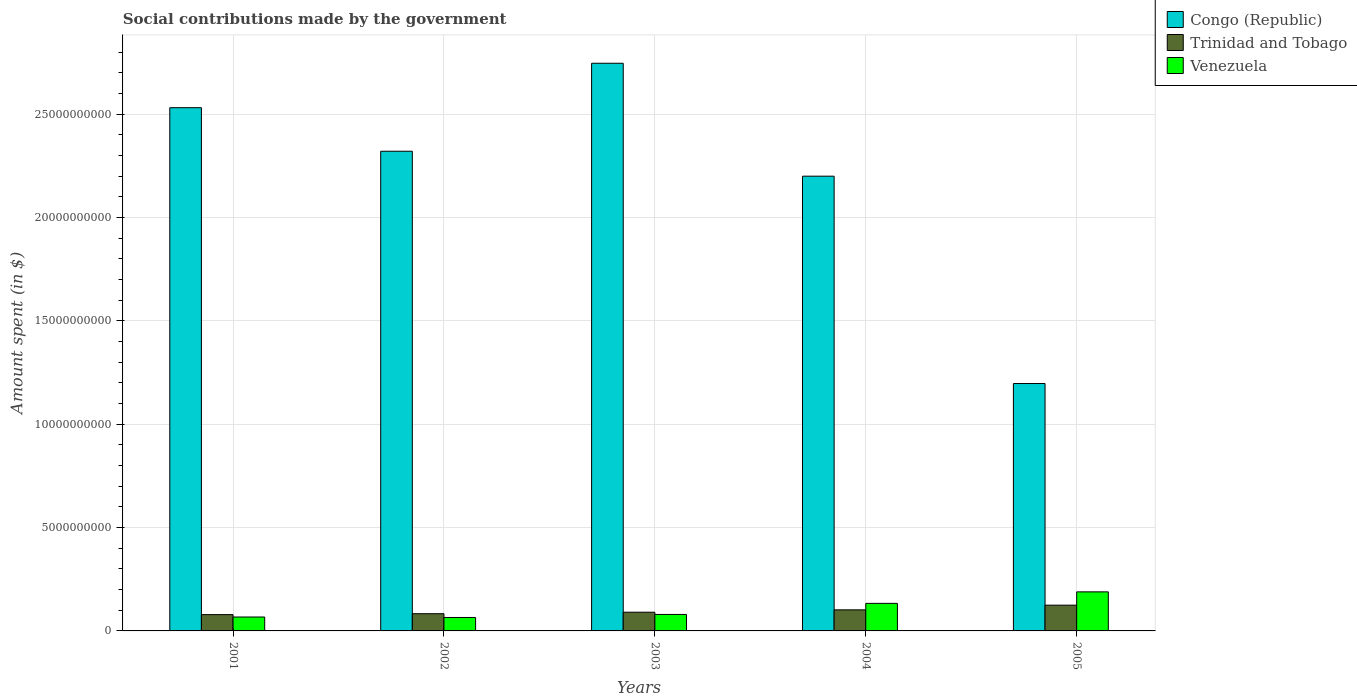How many groups of bars are there?
Make the answer very short. 5. Are the number of bars per tick equal to the number of legend labels?
Give a very brief answer. Yes. How many bars are there on the 5th tick from the right?
Your answer should be very brief. 3. What is the label of the 5th group of bars from the left?
Provide a short and direct response. 2005. In how many cases, is the number of bars for a given year not equal to the number of legend labels?
Offer a very short reply. 0. What is the amount spent on social contributions in Congo (Republic) in 2005?
Your response must be concise. 1.20e+1. Across all years, what is the maximum amount spent on social contributions in Trinidad and Tobago?
Your answer should be very brief. 1.25e+09. Across all years, what is the minimum amount spent on social contributions in Venezuela?
Your answer should be compact. 6.50e+08. In which year was the amount spent on social contributions in Congo (Republic) minimum?
Provide a succinct answer. 2005. What is the total amount spent on social contributions in Congo (Republic) in the graph?
Your answer should be very brief. 1.10e+11. What is the difference between the amount spent on social contributions in Venezuela in 2002 and that in 2004?
Provide a succinct answer. -6.83e+08. What is the difference between the amount spent on social contributions in Congo (Republic) in 2003 and the amount spent on social contributions in Venezuela in 2002?
Give a very brief answer. 2.68e+1. What is the average amount spent on social contributions in Venezuela per year?
Provide a short and direct response. 1.07e+09. In the year 2002, what is the difference between the amount spent on social contributions in Trinidad and Tobago and amount spent on social contributions in Venezuela?
Provide a short and direct response. 1.83e+08. What is the ratio of the amount spent on social contributions in Venezuela in 2003 to that in 2005?
Your response must be concise. 0.42. What is the difference between the highest and the second highest amount spent on social contributions in Congo (Republic)?
Keep it short and to the point. 2.15e+09. What is the difference between the highest and the lowest amount spent on social contributions in Congo (Republic)?
Your answer should be very brief. 1.55e+1. What does the 3rd bar from the left in 2004 represents?
Ensure brevity in your answer.  Venezuela. What does the 2nd bar from the right in 2002 represents?
Provide a succinct answer. Trinidad and Tobago. Is it the case that in every year, the sum of the amount spent on social contributions in Congo (Republic) and amount spent on social contributions in Trinidad and Tobago is greater than the amount spent on social contributions in Venezuela?
Your answer should be compact. Yes. Are all the bars in the graph horizontal?
Give a very brief answer. No. Are the values on the major ticks of Y-axis written in scientific E-notation?
Provide a succinct answer. No. Does the graph contain any zero values?
Ensure brevity in your answer.  No. Does the graph contain grids?
Your answer should be compact. Yes. What is the title of the graph?
Provide a succinct answer. Social contributions made by the government. Does "Angola" appear as one of the legend labels in the graph?
Provide a short and direct response. No. What is the label or title of the X-axis?
Provide a short and direct response. Years. What is the label or title of the Y-axis?
Offer a terse response. Amount spent (in $). What is the Amount spent (in $) in Congo (Republic) in 2001?
Your answer should be very brief. 2.53e+1. What is the Amount spent (in $) of Trinidad and Tobago in 2001?
Keep it short and to the point. 7.89e+08. What is the Amount spent (in $) in Venezuela in 2001?
Ensure brevity in your answer.  6.74e+08. What is the Amount spent (in $) of Congo (Republic) in 2002?
Provide a short and direct response. 2.32e+1. What is the Amount spent (in $) in Trinidad and Tobago in 2002?
Give a very brief answer. 8.33e+08. What is the Amount spent (in $) of Venezuela in 2002?
Provide a succinct answer. 6.50e+08. What is the Amount spent (in $) in Congo (Republic) in 2003?
Keep it short and to the point. 2.75e+1. What is the Amount spent (in $) of Trinidad and Tobago in 2003?
Provide a short and direct response. 9.06e+08. What is the Amount spent (in $) in Venezuela in 2003?
Provide a succinct answer. 7.97e+08. What is the Amount spent (in $) in Congo (Republic) in 2004?
Your response must be concise. 2.20e+1. What is the Amount spent (in $) of Trinidad and Tobago in 2004?
Make the answer very short. 1.02e+09. What is the Amount spent (in $) of Venezuela in 2004?
Ensure brevity in your answer.  1.33e+09. What is the Amount spent (in $) of Congo (Republic) in 2005?
Provide a succinct answer. 1.20e+1. What is the Amount spent (in $) of Trinidad and Tobago in 2005?
Give a very brief answer. 1.25e+09. What is the Amount spent (in $) in Venezuela in 2005?
Provide a succinct answer. 1.89e+09. Across all years, what is the maximum Amount spent (in $) of Congo (Republic)?
Your response must be concise. 2.75e+1. Across all years, what is the maximum Amount spent (in $) of Trinidad and Tobago?
Your answer should be compact. 1.25e+09. Across all years, what is the maximum Amount spent (in $) in Venezuela?
Keep it short and to the point. 1.89e+09. Across all years, what is the minimum Amount spent (in $) in Congo (Republic)?
Ensure brevity in your answer.  1.20e+1. Across all years, what is the minimum Amount spent (in $) of Trinidad and Tobago?
Provide a succinct answer. 7.89e+08. Across all years, what is the minimum Amount spent (in $) of Venezuela?
Your answer should be very brief. 6.50e+08. What is the total Amount spent (in $) in Congo (Republic) in the graph?
Make the answer very short. 1.10e+11. What is the total Amount spent (in $) in Trinidad and Tobago in the graph?
Ensure brevity in your answer.  4.79e+09. What is the total Amount spent (in $) of Venezuela in the graph?
Provide a short and direct response. 5.34e+09. What is the difference between the Amount spent (in $) of Congo (Republic) in 2001 and that in 2002?
Your response must be concise. 2.11e+09. What is the difference between the Amount spent (in $) of Trinidad and Tobago in 2001 and that in 2002?
Make the answer very short. -4.38e+07. What is the difference between the Amount spent (in $) of Venezuela in 2001 and that in 2002?
Offer a terse response. 2.32e+07. What is the difference between the Amount spent (in $) of Congo (Republic) in 2001 and that in 2003?
Provide a succinct answer. -2.15e+09. What is the difference between the Amount spent (in $) in Trinidad and Tobago in 2001 and that in 2003?
Your answer should be compact. -1.16e+08. What is the difference between the Amount spent (in $) of Venezuela in 2001 and that in 2003?
Offer a terse response. -1.23e+08. What is the difference between the Amount spent (in $) of Congo (Republic) in 2001 and that in 2004?
Provide a succinct answer. 3.31e+09. What is the difference between the Amount spent (in $) in Trinidad and Tobago in 2001 and that in 2004?
Make the answer very short. -2.30e+08. What is the difference between the Amount spent (in $) in Venezuela in 2001 and that in 2004?
Offer a very short reply. -6.60e+08. What is the difference between the Amount spent (in $) of Congo (Republic) in 2001 and that in 2005?
Provide a short and direct response. 1.33e+1. What is the difference between the Amount spent (in $) of Trinidad and Tobago in 2001 and that in 2005?
Offer a terse response. -4.57e+08. What is the difference between the Amount spent (in $) in Venezuela in 2001 and that in 2005?
Ensure brevity in your answer.  -1.22e+09. What is the difference between the Amount spent (in $) of Congo (Republic) in 2002 and that in 2003?
Provide a short and direct response. -4.26e+09. What is the difference between the Amount spent (in $) of Trinidad and Tobago in 2002 and that in 2003?
Provide a succinct answer. -7.26e+07. What is the difference between the Amount spent (in $) in Venezuela in 2002 and that in 2003?
Make the answer very short. -1.46e+08. What is the difference between the Amount spent (in $) of Congo (Republic) in 2002 and that in 2004?
Offer a very short reply. 1.21e+09. What is the difference between the Amount spent (in $) in Trinidad and Tobago in 2002 and that in 2004?
Your answer should be compact. -1.87e+08. What is the difference between the Amount spent (in $) in Venezuela in 2002 and that in 2004?
Your answer should be very brief. -6.83e+08. What is the difference between the Amount spent (in $) in Congo (Republic) in 2002 and that in 2005?
Provide a short and direct response. 1.12e+1. What is the difference between the Amount spent (in $) in Trinidad and Tobago in 2002 and that in 2005?
Keep it short and to the point. -4.13e+08. What is the difference between the Amount spent (in $) in Venezuela in 2002 and that in 2005?
Keep it short and to the point. -1.24e+09. What is the difference between the Amount spent (in $) in Congo (Republic) in 2003 and that in 2004?
Your answer should be very brief. 5.46e+09. What is the difference between the Amount spent (in $) in Trinidad and Tobago in 2003 and that in 2004?
Offer a terse response. -1.14e+08. What is the difference between the Amount spent (in $) of Venezuela in 2003 and that in 2004?
Your answer should be compact. -5.37e+08. What is the difference between the Amount spent (in $) in Congo (Republic) in 2003 and that in 2005?
Make the answer very short. 1.55e+1. What is the difference between the Amount spent (in $) in Trinidad and Tobago in 2003 and that in 2005?
Keep it short and to the point. -3.40e+08. What is the difference between the Amount spent (in $) in Venezuela in 2003 and that in 2005?
Offer a terse response. -1.09e+09. What is the difference between the Amount spent (in $) in Congo (Republic) in 2004 and that in 2005?
Give a very brief answer. 1.00e+1. What is the difference between the Amount spent (in $) in Trinidad and Tobago in 2004 and that in 2005?
Keep it short and to the point. -2.26e+08. What is the difference between the Amount spent (in $) in Venezuela in 2004 and that in 2005?
Offer a very short reply. -5.56e+08. What is the difference between the Amount spent (in $) in Congo (Republic) in 2001 and the Amount spent (in $) in Trinidad and Tobago in 2002?
Your response must be concise. 2.45e+1. What is the difference between the Amount spent (in $) of Congo (Republic) in 2001 and the Amount spent (in $) of Venezuela in 2002?
Provide a succinct answer. 2.47e+1. What is the difference between the Amount spent (in $) in Trinidad and Tobago in 2001 and the Amount spent (in $) in Venezuela in 2002?
Ensure brevity in your answer.  1.39e+08. What is the difference between the Amount spent (in $) of Congo (Republic) in 2001 and the Amount spent (in $) of Trinidad and Tobago in 2003?
Your answer should be very brief. 2.44e+1. What is the difference between the Amount spent (in $) of Congo (Republic) in 2001 and the Amount spent (in $) of Venezuela in 2003?
Ensure brevity in your answer.  2.45e+1. What is the difference between the Amount spent (in $) in Trinidad and Tobago in 2001 and the Amount spent (in $) in Venezuela in 2003?
Give a very brief answer. -7.62e+06. What is the difference between the Amount spent (in $) of Congo (Republic) in 2001 and the Amount spent (in $) of Trinidad and Tobago in 2004?
Your answer should be compact. 2.43e+1. What is the difference between the Amount spent (in $) in Congo (Republic) in 2001 and the Amount spent (in $) in Venezuela in 2004?
Make the answer very short. 2.40e+1. What is the difference between the Amount spent (in $) of Trinidad and Tobago in 2001 and the Amount spent (in $) of Venezuela in 2004?
Your response must be concise. -5.44e+08. What is the difference between the Amount spent (in $) of Congo (Republic) in 2001 and the Amount spent (in $) of Trinidad and Tobago in 2005?
Your answer should be very brief. 2.41e+1. What is the difference between the Amount spent (in $) in Congo (Republic) in 2001 and the Amount spent (in $) in Venezuela in 2005?
Make the answer very short. 2.34e+1. What is the difference between the Amount spent (in $) of Trinidad and Tobago in 2001 and the Amount spent (in $) of Venezuela in 2005?
Offer a very short reply. -1.10e+09. What is the difference between the Amount spent (in $) of Congo (Republic) in 2002 and the Amount spent (in $) of Trinidad and Tobago in 2003?
Make the answer very short. 2.23e+1. What is the difference between the Amount spent (in $) of Congo (Republic) in 2002 and the Amount spent (in $) of Venezuela in 2003?
Your response must be concise. 2.24e+1. What is the difference between the Amount spent (in $) of Trinidad and Tobago in 2002 and the Amount spent (in $) of Venezuela in 2003?
Make the answer very short. 3.62e+07. What is the difference between the Amount spent (in $) in Congo (Republic) in 2002 and the Amount spent (in $) in Trinidad and Tobago in 2004?
Provide a short and direct response. 2.22e+1. What is the difference between the Amount spent (in $) of Congo (Republic) in 2002 and the Amount spent (in $) of Venezuela in 2004?
Your response must be concise. 2.19e+1. What is the difference between the Amount spent (in $) of Trinidad and Tobago in 2002 and the Amount spent (in $) of Venezuela in 2004?
Keep it short and to the point. -5.00e+08. What is the difference between the Amount spent (in $) of Congo (Republic) in 2002 and the Amount spent (in $) of Trinidad and Tobago in 2005?
Ensure brevity in your answer.  2.20e+1. What is the difference between the Amount spent (in $) in Congo (Republic) in 2002 and the Amount spent (in $) in Venezuela in 2005?
Offer a very short reply. 2.13e+1. What is the difference between the Amount spent (in $) of Trinidad and Tobago in 2002 and the Amount spent (in $) of Venezuela in 2005?
Offer a terse response. -1.06e+09. What is the difference between the Amount spent (in $) in Congo (Republic) in 2003 and the Amount spent (in $) in Trinidad and Tobago in 2004?
Make the answer very short. 2.64e+1. What is the difference between the Amount spent (in $) in Congo (Republic) in 2003 and the Amount spent (in $) in Venezuela in 2004?
Keep it short and to the point. 2.61e+1. What is the difference between the Amount spent (in $) of Trinidad and Tobago in 2003 and the Amount spent (in $) of Venezuela in 2004?
Offer a very short reply. -4.28e+08. What is the difference between the Amount spent (in $) of Congo (Republic) in 2003 and the Amount spent (in $) of Trinidad and Tobago in 2005?
Provide a short and direct response. 2.62e+1. What is the difference between the Amount spent (in $) of Congo (Republic) in 2003 and the Amount spent (in $) of Venezuela in 2005?
Give a very brief answer. 2.56e+1. What is the difference between the Amount spent (in $) in Trinidad and Tobago in 2003 and the Amount spent (in $) in Venezuela in 2005?
Offer a terse response. -9.84e+08. What is the difference between the Amount spent (in $) of Congo (Republic) in 2004 and the Amount spent (in $) of Trinidad and Tobago in 2005?
Offer a terse response. 2.08e+1. What is the difference between the Amount spent (in $) of Congo (Republic) in 2004 and the Amount spent (in $) of Venezuela in 2005?
Keep it short and to the point. 2.01e+1. What is the difference between the Amount spent (in $) in Trinidad and Tobago in 2004 and the Amount spent (in $) in Venezuela in 2005?
Make the answer very short. -8.70e+08. What is the average Amount spent (in $) in Congo (Republic) per year?
Give a very brief answer. 2.20e+1. What is the average Amount spent (in $) in Trinidad and Tobago per year?
Your answer should be very brief. 9.59e+08. What is the average Amount spent (in $) in Venezuela per year?
Offer a very short reply. 1.07e+09. In the year 2001, what is the difference between the Amount spent (in $) of Congo (Republic) and Amount spent (in $) of Trinidad and Tobago?
Keep it short and to the point. 2.45e+1. In the year 2001, what is the difference between the Amount spent (in $) in Congo (Republic) and Amount spent (in $) in Venezuela?
Make the answer very short. 2.46e+1. In the year 2001, what is the difference between the Amount spent (in $) of Trinidad and Tobago and Amount spent (in $) of Venezuela?
Your answer should be very brief. 1.16e+08. In the year 2002, what is the difference between the Amount spent (in $) in Congo (Republic) and Amount spent (in $) in Trinidad and Tobago?
Keep it short and to the point. 2.24e+1. In the year 2002, what is the difference between the Amount spent (in $) in Congo (Republic) and Amount spent (in $) in Venezuela?
Provide a short and direct response. 2.26e+1. In the year 2002, what is the difference between the Amount spent (in $) of Trinidad and Tobago and Amount spent (in $) of Venezuela?
Ensure brevity in your answer.  1.83e+08. In the year 2003, what is the difference between the Amount spent (in $) of Congo (Republic) and Amount spent (in $) of Trinidad and Tobago?
Your answer should be compact. 2.66e+1. In the year 2003, what is the difference between the Amount spent (in $) of Congo (Republic) and Amount spent (in $) of Venezuela?
Keep it short and to the point. 2.67e+1. In the year 2003, what is the difference between the Amount spent (in $) in Trinidad and Tobago and Amount spent (in $) in Venezuela?
Ensure brevity in your answer.  1.09e+08. In the year 2004, what is the difference between the Amount spent (in $) in Congo (Republic) and Amount spent (in $) in Trinidad and Tobago?
Your response must be concise. 2.10e+1. In the year 2004, what is the difference between the Amount spent (in $) in Congo (Republic) and Amount spent (in $) in Venezuela?
Make the answer very short. 2.07e+1. In the year 2004, what is the difference between the Amount spent (in $) of Trinidad and Tobago and Amount spent (in $) of Venezuela?
Give a very brief answer. -3.14e+08. In the year 2005, what is the difference between the Amount spent (in $) of Congo (Republic) and Amount spent (in $) of Trinidad and Tobago?
Make the answer very short. 1.07e+1. In the year 2005, what is the difference between the Amount spent (in $) of Congo (Republic) and Amount spent (in $) of Venezuela?
Your answer should be very brief. 1.01e+1. In the year 2005, what is the difference between the Amount spent (in $) of Trinidad and Tobago and Amount spent (in $) of Venezuela?
Provide a succinct answer. -6.44e+08. What is the ratio of the Amount spent (in $) of Congo (Republic) in 2001 to that in 2002?
Your answer should be very brief. 1.09. What is the ratio of the Amount spent (in $) of Trinidad and Tobago in 2001 to that in 2002?
Provide a succinct answer. 0.95. What is the ratio of the Amount spent (in $) in Venezuela in 2001 to that in 2002?
Give a very brief answer. 1.04. What is the ratio of the Amount spent (in $) of Congo (Republic) in 2001 to that in 2003?
Provide a succinct answer. 0.92. What is the ratio of the Amount spent (in $) of Trinidad and Tobago in 2001 to that in 2003?
Provide a succinct answer. 0.87. What is the ratio of the Amount spent (in $) in Venezuela in 2001 to that in 2003?
Your answer should be very brief. 0.85. What is the ratio of the Amount spent (in $) of Congo (Republic) in 2001 to that in 2004?
Keep it short and to the point. 1.15. What is the ratio of the Amount spent (in $) of Trinidad and Tobago in 2001 to that in 2004?
Provide a short and direct response. 0.77. What is the ratio of the Amount spent (in $) of Venezuela in 2001 to that in 2004?
Provide a succinct answer. 0.51. What is the ratio of the Amount spent (in $) of Congo (Republic) in 2001 to that in 2005?
Your response must be concise. 2.12. What is the ratio of the Amount spent (in $) in Trinidad and Tobago in 2001 to that in 2005?
Your answer should be compact. 0.63. What is the ratio of the Amount spent (in $) in Venezuela in 2001 to that in 2005?
Keep it short and to the point. 0.36. What is the ratio of the Amount spent (in $) of Congo (Republic) in 2002 to that in 2003?
Your answer should be very brief. 0.84. What is the ratio of the Amount spent (in $) of Trinidad and Tobago in 2002 to that in 2003?
Your response must be concise. 0.92. What is the ratio of the Amount spent (in $) in Venezuela in 2002 to that in 2003?
Your answer should be very brief. 0.82. What is the ratio of the Amount spent (in $) in Congo (Republic) in 2002 to that in 2004?
Offer a terse response. 1.05. What is the ratio of the Amount spent (in $) in Trinidad and Tobago in 2002 to that in 2004?
Offer a terse response. 0.82. What is the ratio of the Amount spent (in $) of Venezuela in 2002 to that in 2004?
Your answer should be very brief. 0.49. What is the ratio of the Amount spent (in $) of Congo (Republic) in 2002 to that in 2005?
Your response must be concise. 1.94. What is the ratio of the Amount spent (in $) in Trinidad and Tobago in 2002 to that in 2005?
Provide a short and direct response. 0.67. What is the ratio of the Amount spent (in $) of Venezuela in 2002 to that in 2005?
Make the answer very short. 0.34. What is the ratio of the Amount spent (in $) of Congo (Republic) in 2003 to that in 2004?
Provide a succinct answer. 1.25. What is the ratio of the Amount spent (in $) in Trinidad and Tobago in 2003 to that in 2004?
Offer a very short reply. 0.89. What is the ratio of the Amount spent (in $) in Venezuela in 2003 to that in 2004?
Your response must be concise. 0.6. What is the ratio of the Amount spent (in $) in Congo (Republic) in 2003 to that in 2005?
Your answer should be very brief. 2.29. What is the ratio of the Amount spent (in $) in Trinidad and Tobago in 2003 to that in 2005?
Offer a very short reply. 0.73. What is the ratio of the Amount spent (in $) of Venezuela in 2003 to that in 2005?
Ensure brevity in your answer.  0.42. What is the ratio of the Amount spent (in $) of Congo (Republic) in 2004 to that in 2005?
Provide a short and direct response. 1.84. What is the ratio of the Amount spent (in $) in Trinidad and Tobago in 2004 to that in 2005?
Your response must be concise. 0.82. What is the ratio of the Amount spent (in $) of Venezuela in 2004 to that in 2005?
Your answer should be compact. 0.71. What is the difference between the highest and the second highest Amount spent (in $) of Congo (Republic)?
Keep it short and to the point. 2.15e+09. What is the difference between the highest and the second highest Amount spent (in $) of Trinidad and Tobago?
Ensure brevity in your answer.  2.26e+08. What is the difference between the highest and the second highest Amount spent (in $) in Venezuela?
Your answer should be very brief. 5.56e+08. What is the difference between the highest and the lowest Amount spent (in $) in Congo (Republic)?
Offer a very short reply. 1.55e+1. What is the difference between the highest and the lowest Amount spent (in $) in Trinidad and Tobago?
Offer a terse response. 4.57e+08. What is the difference between the highest and the lowest Amount spent (in $) in Venezuela?
Your answer should be very brief. 1.24e+09. 